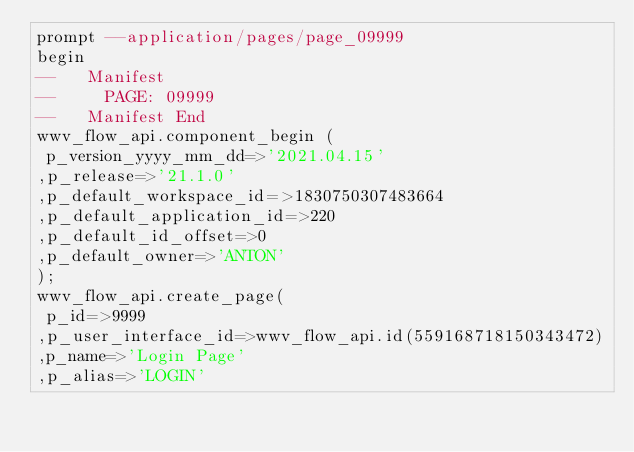<code> <loc_0><loc_0><loc_500><loc_500><_SQL_>prompt --application/pages/page_09999
begin
--   Manifest
--     PAGE: 09999
--   Manifest End
wwv_flow_api.component_begin (
 p_version_yyyy_mm_dd=>'2021.04.15'
,p_release=>'21.1.0'
,p_default_workspace_id=>1830750307483664
,p_default_application_id=>220
,p_default_id_offset=>0
,p_default_owner=>'ANTON'
);
wwv_flow_api.create_page(
 p_id=>9999
,p_user_interface_id=>wwv_flow_api.id(559168718150343472)
,p_name=>'Login Page'
,p_alias=>'LOGIN'</code> 